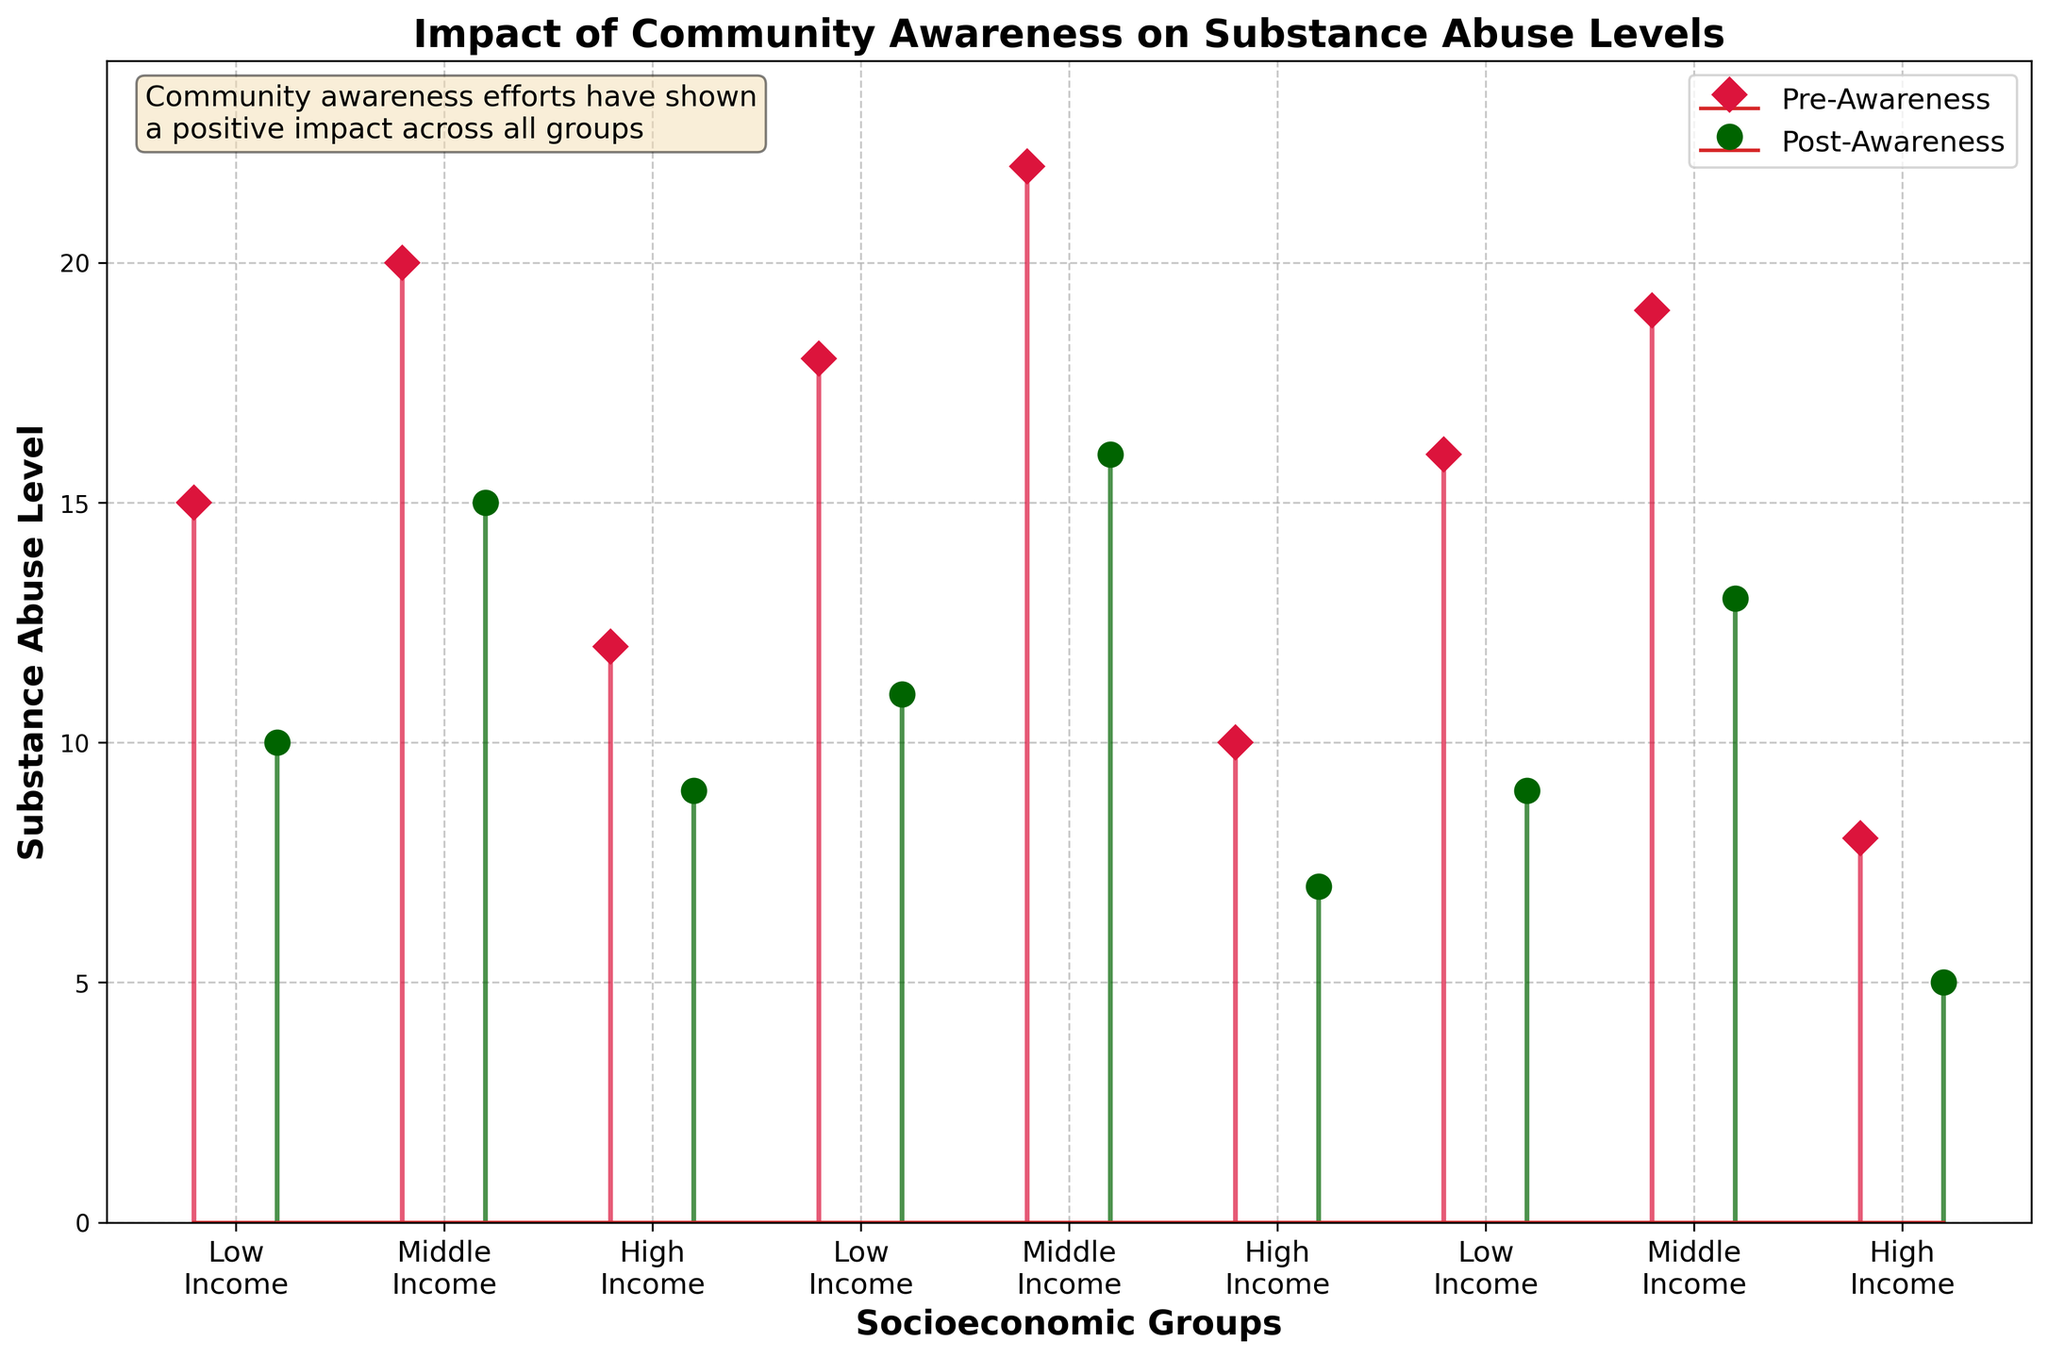what is the title of the plot? The title is located at the top of the plot and summarizes the main idea of the figure.
Answer: "Impact of Community Awareness on Substance Abuse Levels" What colors are used to represent pre-awareness and post-awareness levels? The colors of the markers and stem lines differentiate the pre-awareness and post-awareness levels. Pre-awareness is represented by crimson and post-awareness is represented by dark green.
Answer: Crimson and Dark Green How many socioeconomic groups are compared in the figure? The x-axis labels provide the names of the socioeconomic groups compared.
Answer: 3 (Low Income, Middle Income, High Income) What is the substance abuse level of the middle-income group before and after the awareness efforts for the first data point? By examining the stem lines for the middle-income group, we can find the corresponding substance abuse levels before and after awareness efforts.
Answer: 20 (Pre) and 15 (Post) Which socioeconomic group showed the highest substance abuse level before awareness efforts? By comparing the heights of the stem lines labeled 'Pre-Awareness' across the three groups, we can identify the highest level.
Answer: Middle Income On average, how did the substance abuse levels change for the low-income group after the awareness efforts? Calculate the difference between pre-awareness and post-awareness levels for each data point in the low-income group, then find the average of these differences. (15-10), (18-11), (16-9) = 5, 7, 7 -> (5+7+7)/3 = 6.33
Answer: 6.33 Which group showed the least improvement in substance abuse levels post-awareness? Compare the differences in pre-awareness and post-awareness levels for each socioeconomic group and identify the smallest change.
Answer: High Income 